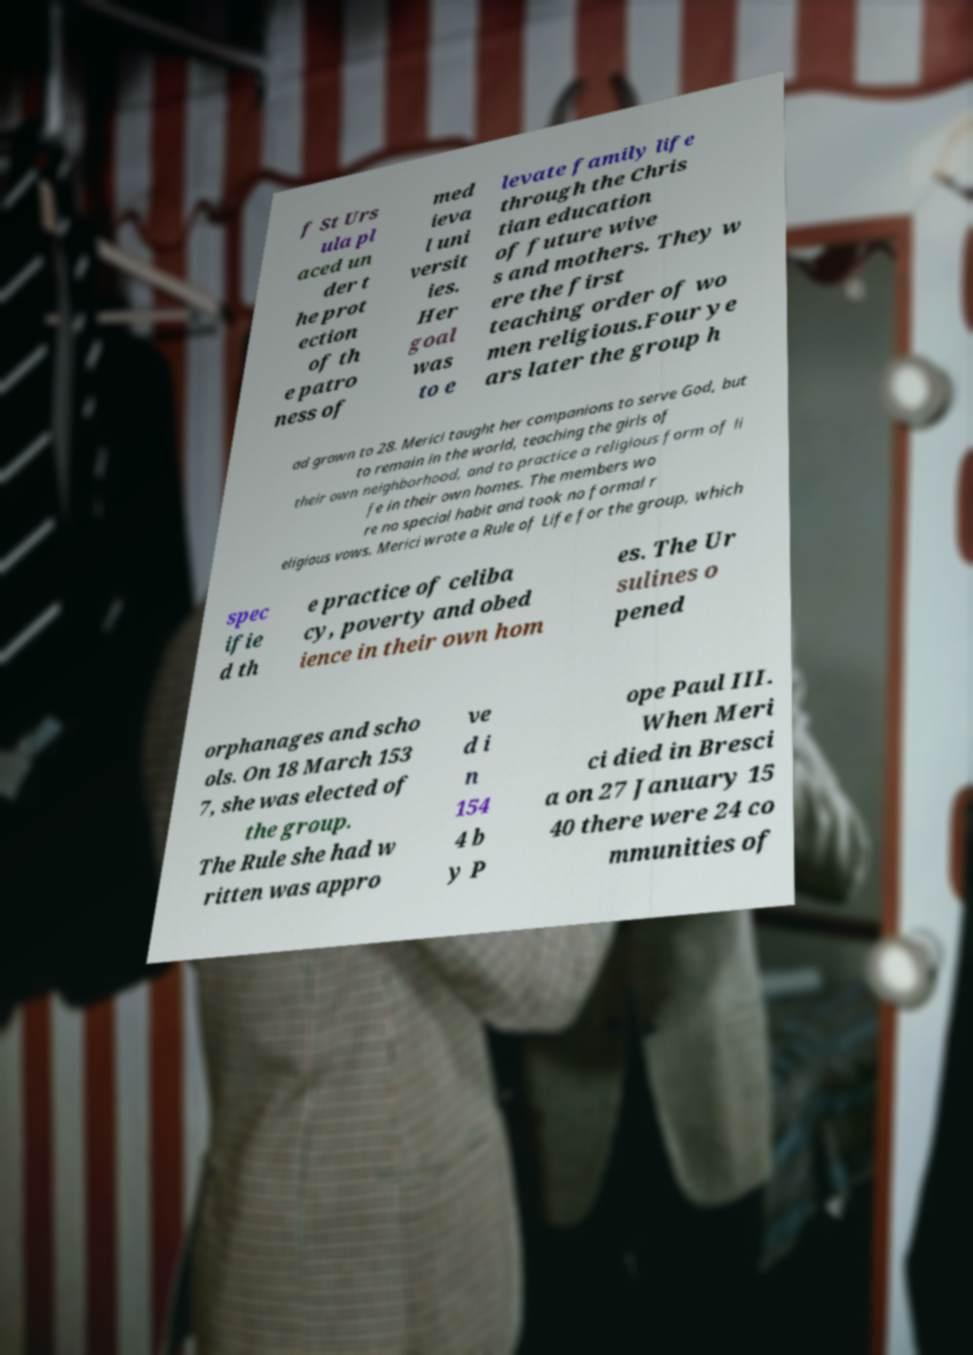There's text embedded in this image that I need extracted. Can you transcribe it verbatim? f St Urs ula pl aced un der t he prot ection of th e patro ness of med ieva l uni versit ies. Her goal was to e levate family life through the Chris tian education of future wive s and mothers. They w ere the first teaching order of wo men religious.Four ye ars later the group h ad grown to 28. Merici taught her companions to serve God, but to remain in the world, teaching the girls of their own neighborhood, and to practice a religious form of li fe in their own homes. The members wo re no special habit and took no formal r eligious vows. Merici wrote a Rule of Life for the group, which spec ifie d th e practice of celiba cy, poverty and obed ience in their own hom es. The Ur sulines o pened orphanages and scho ols. On 18 March 153 7, she was elected of the group. The Rule she had w ritten was appro ve d i n 154 4 b y P ope Paul III. When Meri ci died in Bresci a on 27 January 15 40 there were 24 co mmunities of 